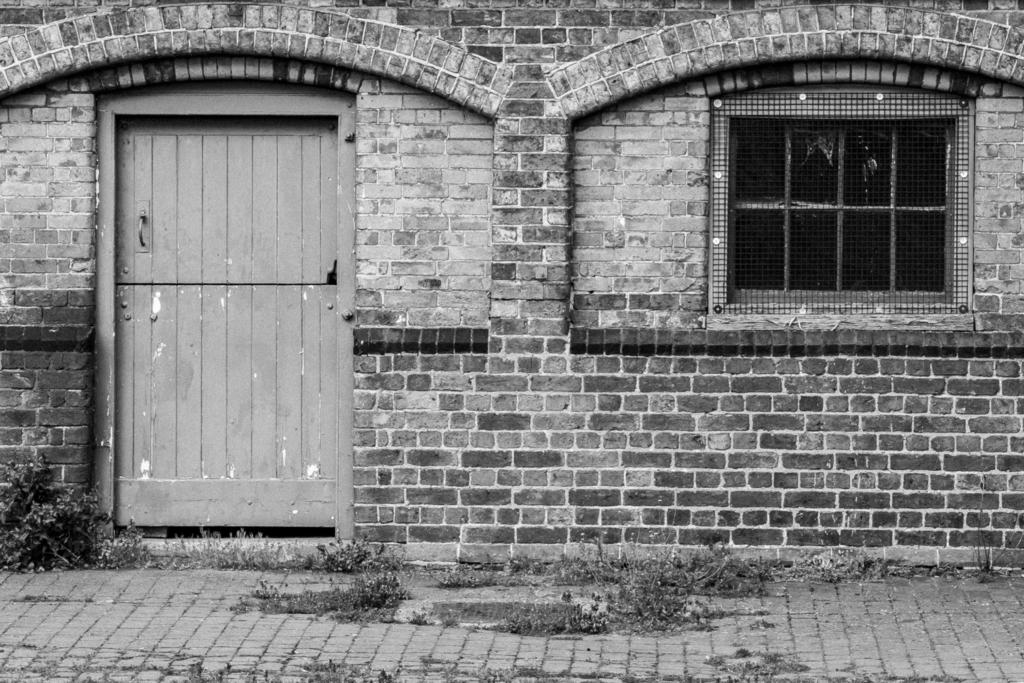What type of structure is visible in the image? There is a building in the image. What is one of the main features of the building? There is a door in the image. Are there any openings in the building that allow for light and ventilation? Yes, there is a window in the image. What type of meat is being served at the table in the image? There is no table or meat present in the image; it only features a building, door, and window. 